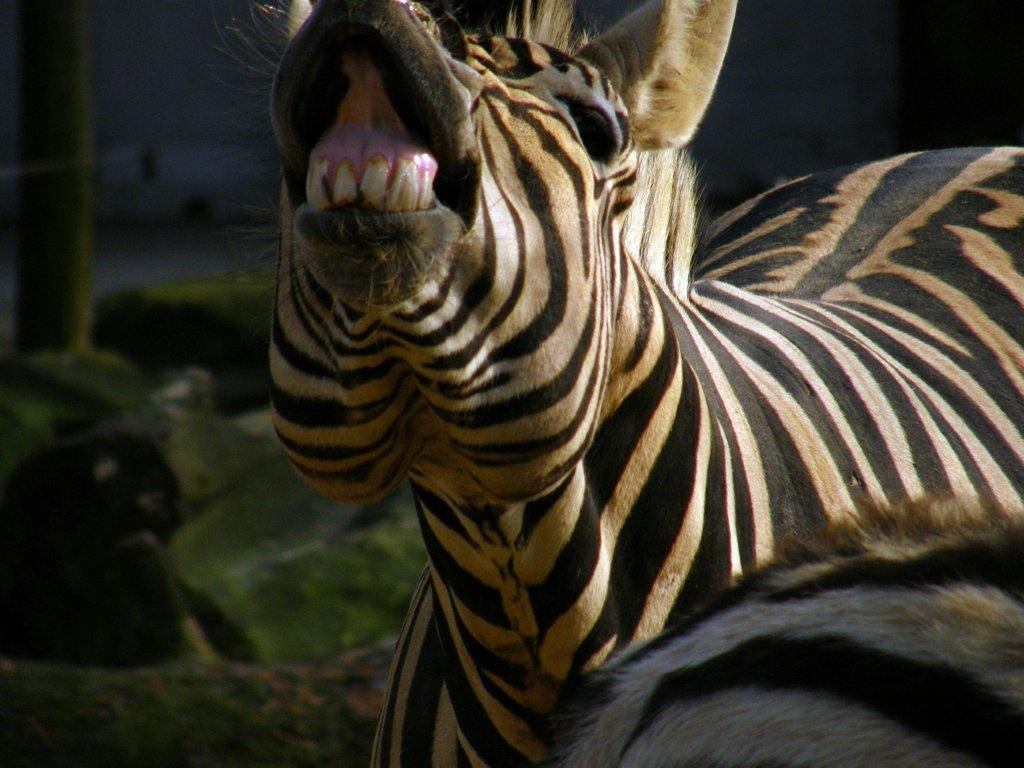What type of animal is in the image? The animal in the image has black and brown coloring. Can you describe the color pattern of the animal? The animal has black and brown coloring. What can be observed about the background of the image? The background of the image is blurred. What type of knowledge can be seen written on the note in the image? There is no note present in the image, so it is not possible to determine what type of knowledge might be written on it. 